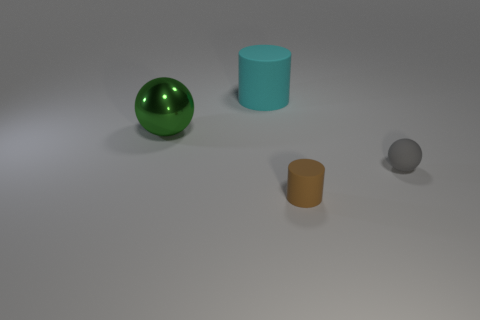What is the material of the tiny cylinder?
Give a very brief answer. Rubber. What is the shape of the other thing that is the same size as the brown rubber thing?
Your answer should be very brief. Sphere. What number of other things are the same color as the large rubber cylinder?
Keep it short and to the point. 0. The small rubber object left of the small gray matte object is what color?
Provide a short and direct response. Brown. What number of other objects are the same material as the green sphere?
Offer a very short reply. 0. Is the number of objects on the right side of the big cyan object greater than the number of big cyan cylinders in front of the gray rubber object?
Offer a very short reply. Yes. How many green balls are in front of the small gray rubber ball?
Ensure brevity in your answer.  0. Does the small ball have the same material as the cylinder that is in front of the small gray matte object?
Offer a terse response. Yes. Is the material of the cyan cylinder the same as the brown thing?
Provide a succinct answer. Yes. There is a thing behind the green shiny object; are there any brown objects behind it?
Give a very brief answer. No. 